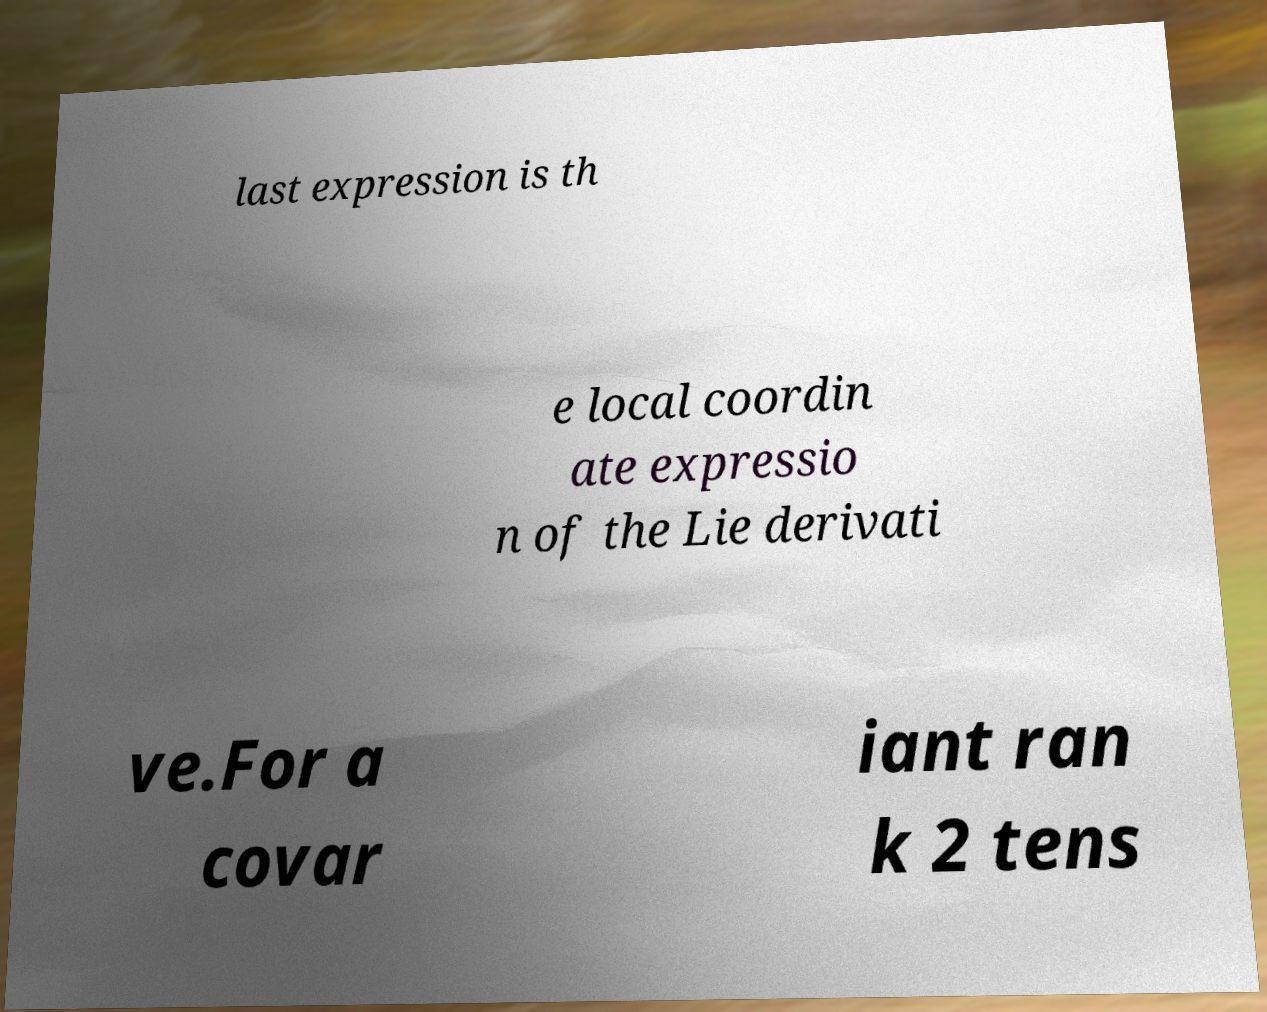Could you extract and type out the text from this image? last expression is th e local coordin ate expressio n of the Lie derivati ve.For a covar iant ran k 2 tens 